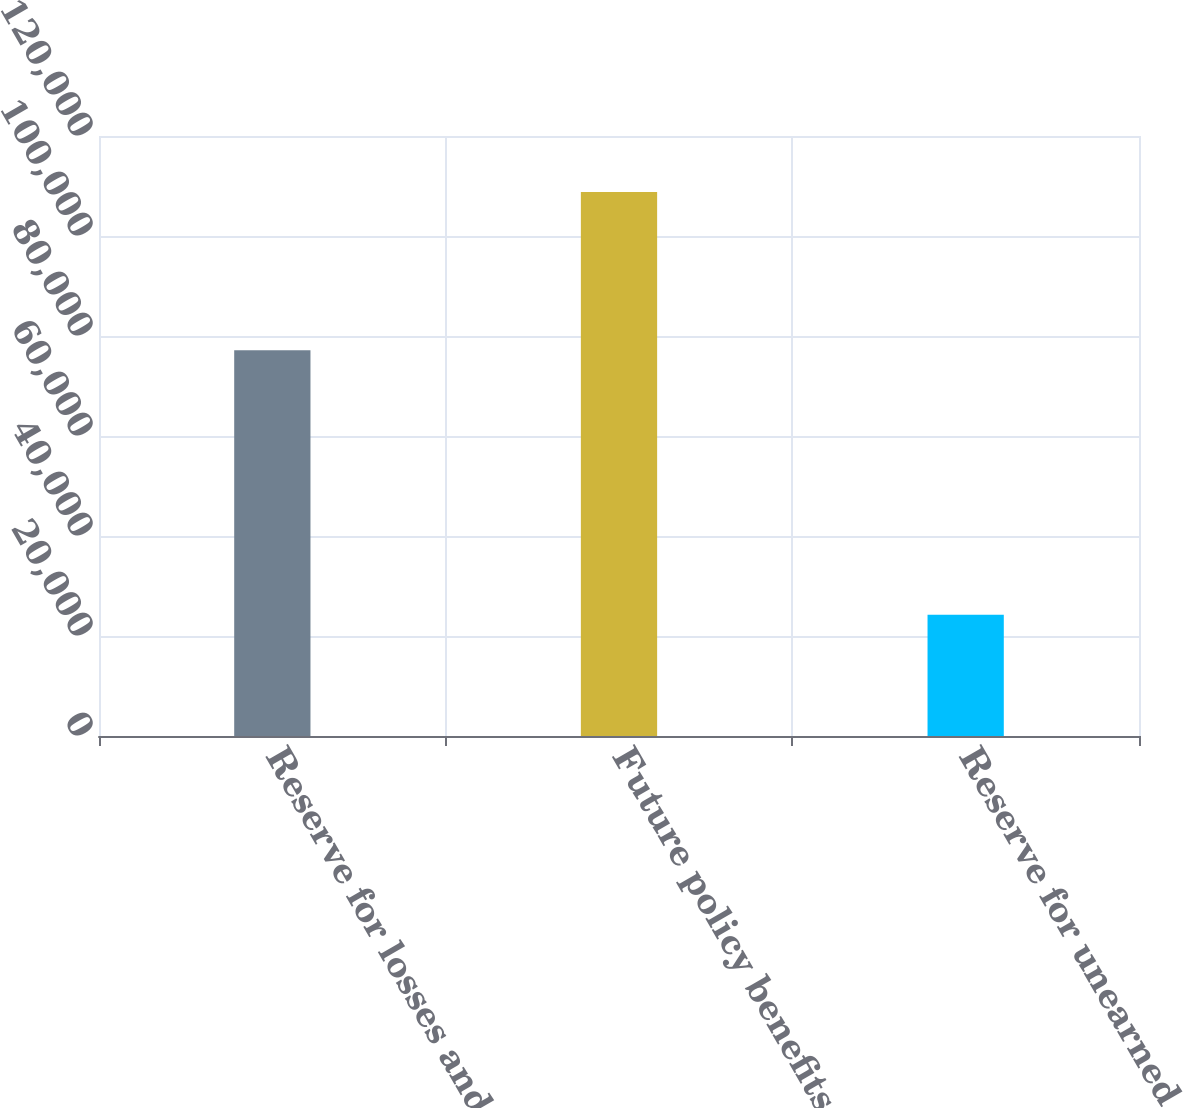<chart> <loc_0><loc_0><loc_500><loc_500><bar_chart><fcel>Reserve for losses and loss<fcel>Future policy benefits for<fcel>Reserve for unearned premiums<nl><fcel>77169<fcel>108807<fcel>24243<nl></chart> 